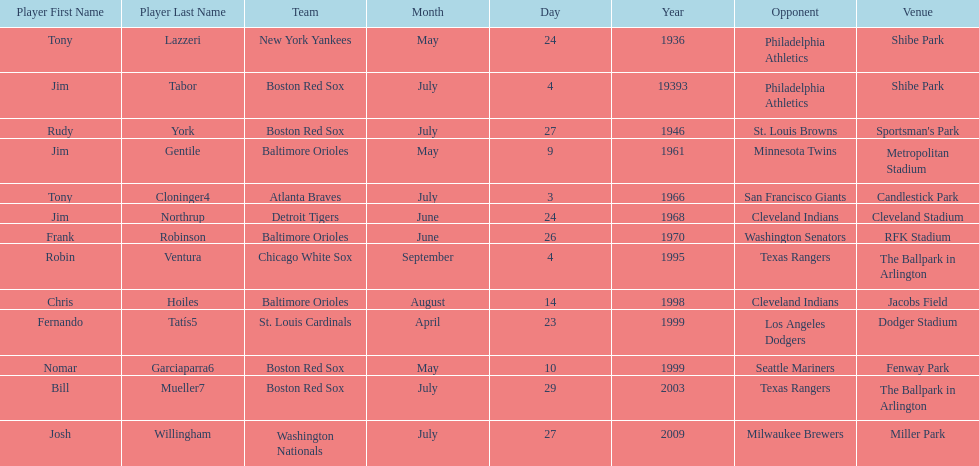What was the name of the player who accomplished this in 1999 but played for the boston red sox? Nomar Garciaparra. 